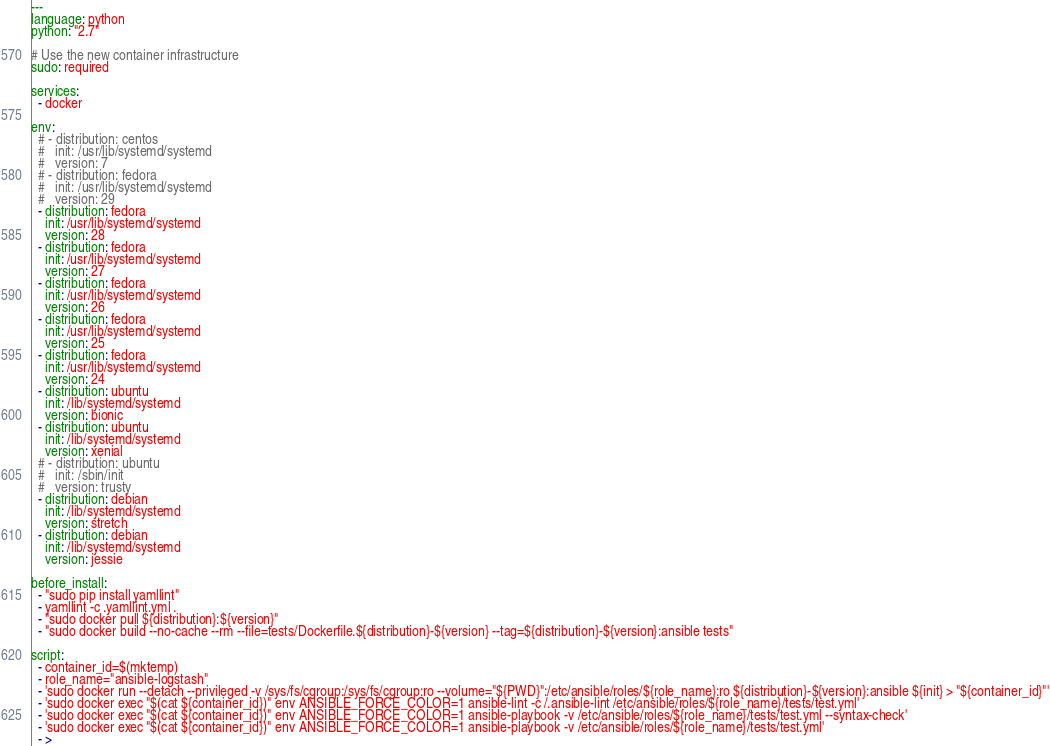Convert code to text. <code><loc_0><loc_0><loc_500><loc_500><_YAML_>---
language: python
python: "2.7"

# Use the new container infrastructure
sudo: required

services:
  - docker

env:
  # - distribution: centos
  #   init: /usr/lib/systemd/systemd
  #   version: 7
  # - distribution: fedora
  #   init: /usr/lib/systemd/systemd
  #   version: 29
  - distribution: fedora
    init: /usr/lib/systemd/systemd
    version: 28
  - distribution: fedora
    init: /usr/lib/systemd/systemd
    version: 27
  - distribution: fedora
    init: /usr/lib/systemd/systemd
    version: 26
  - distribution: fedora
    init: /usr/lib/systemd/systemd
    version: 25
  - distribution: fedora
    init: /usr/lib/systemd/systemd
    version: 24
  - distribution: ubuntu
    init: /lib/systemd/systemd
    version: bionic
  - distribution: ubuntu
    init: /lib/systemd/systemd
    version: xenial
  # - distribution: ubuntu
  #   init: /sbin/init
  #   version: trusty
  - distribution: debian
    init: /lib/systemd/systemd
    version: stretch
  - distribution: debian
    init: /lib/systemd/systemd
    version: jessie

before_install:
  - "sudo pip install yamllint"
  - yamllint -c .yamllint.yml .
  - "sudo docker pull ${distribution}:${version}"
  - "sudo docker build --no-cache --rm --file=tests/Dockerfile.${distribution}-${version} --tag=${distribution}-${version}:ansible tests"

script:
  - container_id=$(mktemp)
  - role_name="ansible-logstash"
  - 'sudo docker run --detach --privileged -v /sys/fs/cgroup:/sys/fs/cgroup:ro --volume="${PWD}":/etc/ansible/roles/${role_name}:ro ${distribution}-${version}:ansible ${init} > "${container_id}"'
  - 'sudo docker exec "$(cat ${container_id})" env ANSIBLE_FORCE_COLOR=1 ansible-lint -c /.ansible-lint /etc/ansible/roles/${role_name}/tests/test.yml'
  - 'sudo docker exec "$(cat ${container_id})" env ANSIBLE_FORCE_COLOR=1 ansible-playbook -v /etc/ansible/roles/${role_name}/tests/test.yml --syntax-check'
  - 'sudo docker exec "$(cat ${container_id})" env ANSIBLE_FORCE_COLOR=1 ansible-playbook -v /etc/ansible/roles/${role_name}/tests/test.yml'
  - ></code> 